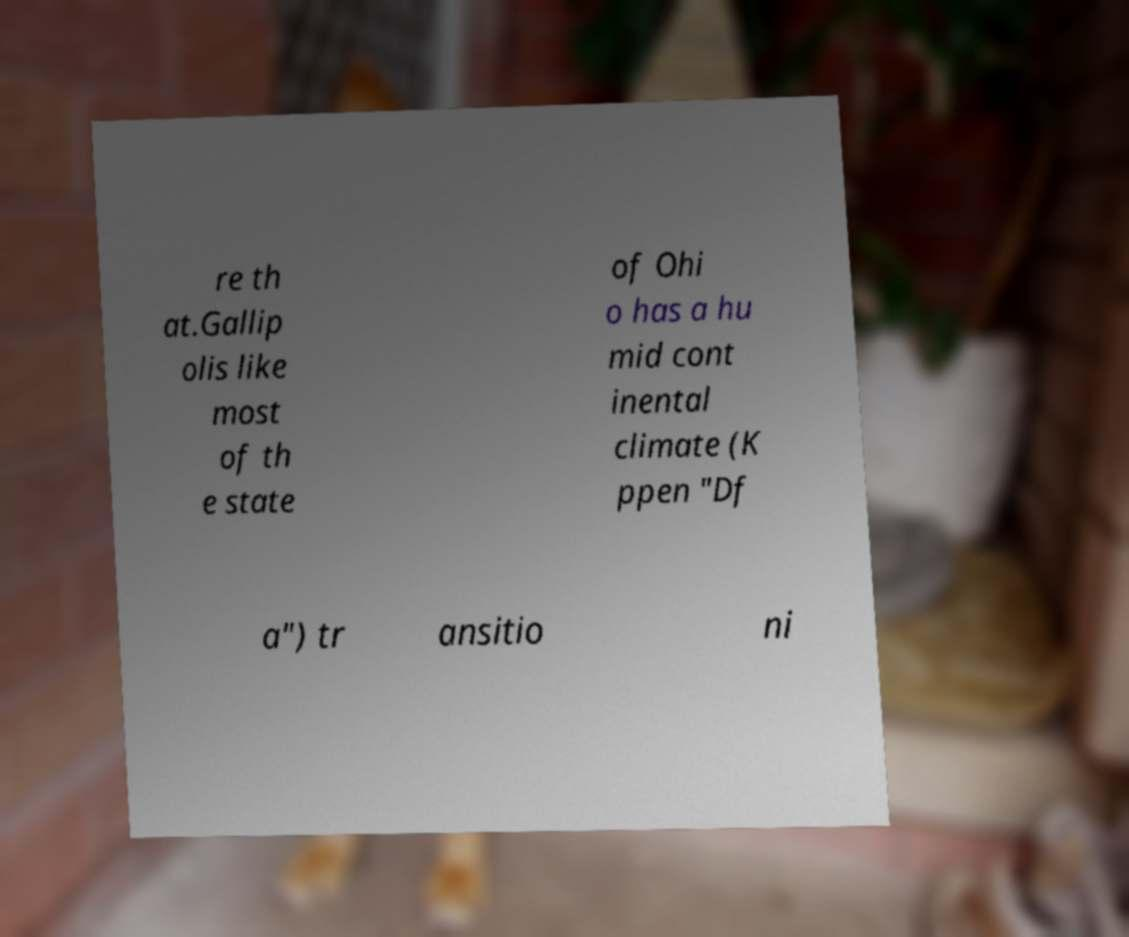Can you read and provide the text displayed in the image?This photo seems to have some interesting text. Can you extract and type it out for me? re th at.Gallip olis like most of th e state of Ohi o has a hu mid cont inental climate (K ppen "Df a") tr ansitio ni 